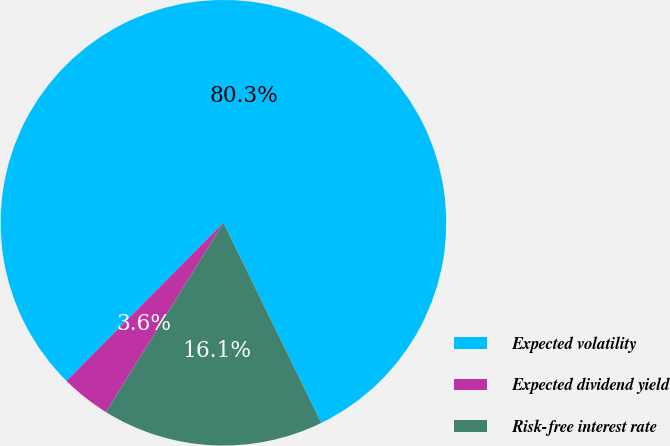<chart> <loc_0><loc_0><loc_500><loc_500><pie_chart><fcel>Expected volatility<fcel>Expected dividend yield<fcel>Risk-free interest rate<nl><fcel>80.33%<fcel>3.6%<fcel>16.07%<nl></chart> 